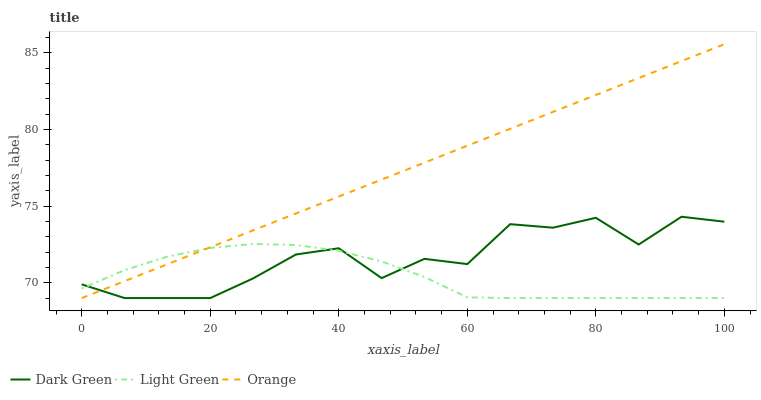Does Dark Green have the minimum area under the curve?
Answer yes or no. No. Does Dark Green have the maximum area under the curve?
Answer yes or no. No. Is Light Green the smoothest?
Answer yes or no. No. Is Light Green the roughest?
Answer yes or no. No. Does Dark Green have the highest value?
Answer yes or no. No. 